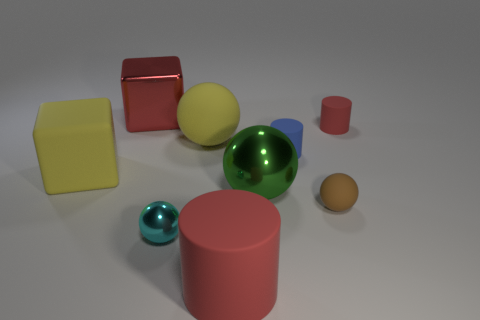Subtract 1 balls. How many balls are left? 3 Add 1 matte spheres. How many objects exist? 10 Subtract all cubes. How many objects are left? 7 Add 6 red metallic cubes. How many red metallic cubes are left? 7 Add 9 small yellow matte blocks. How many small yellow matte blocks exist? 9 Subtract 2 red cylinders. How many objects are left? 7 Subtract all cyan metallic things. Subtract all cylinders. How many objects are left? 5 